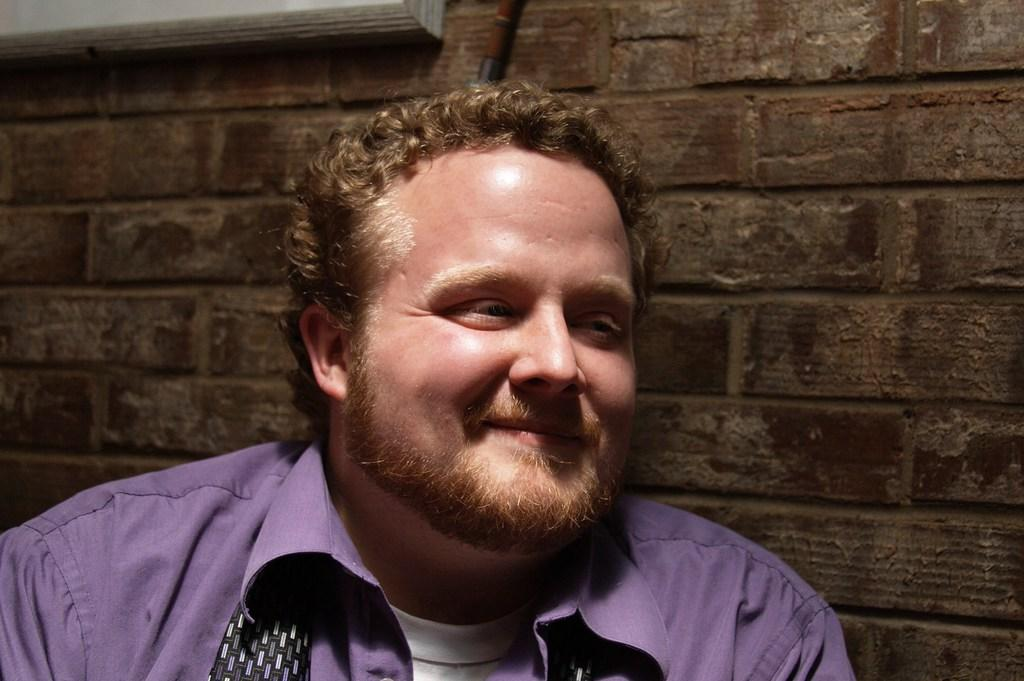What is the main subject of the image? There is a man in the image. What is the man's facial expression in the image? The man is smiling in the image. What can be seen in the background of the image? There is a wall visible in the background of the image. What type of detail can be seen on the man's head in the image? There is no specific detail mentioned on the man's head in the provided facts, so it cannot be determined from the image. 